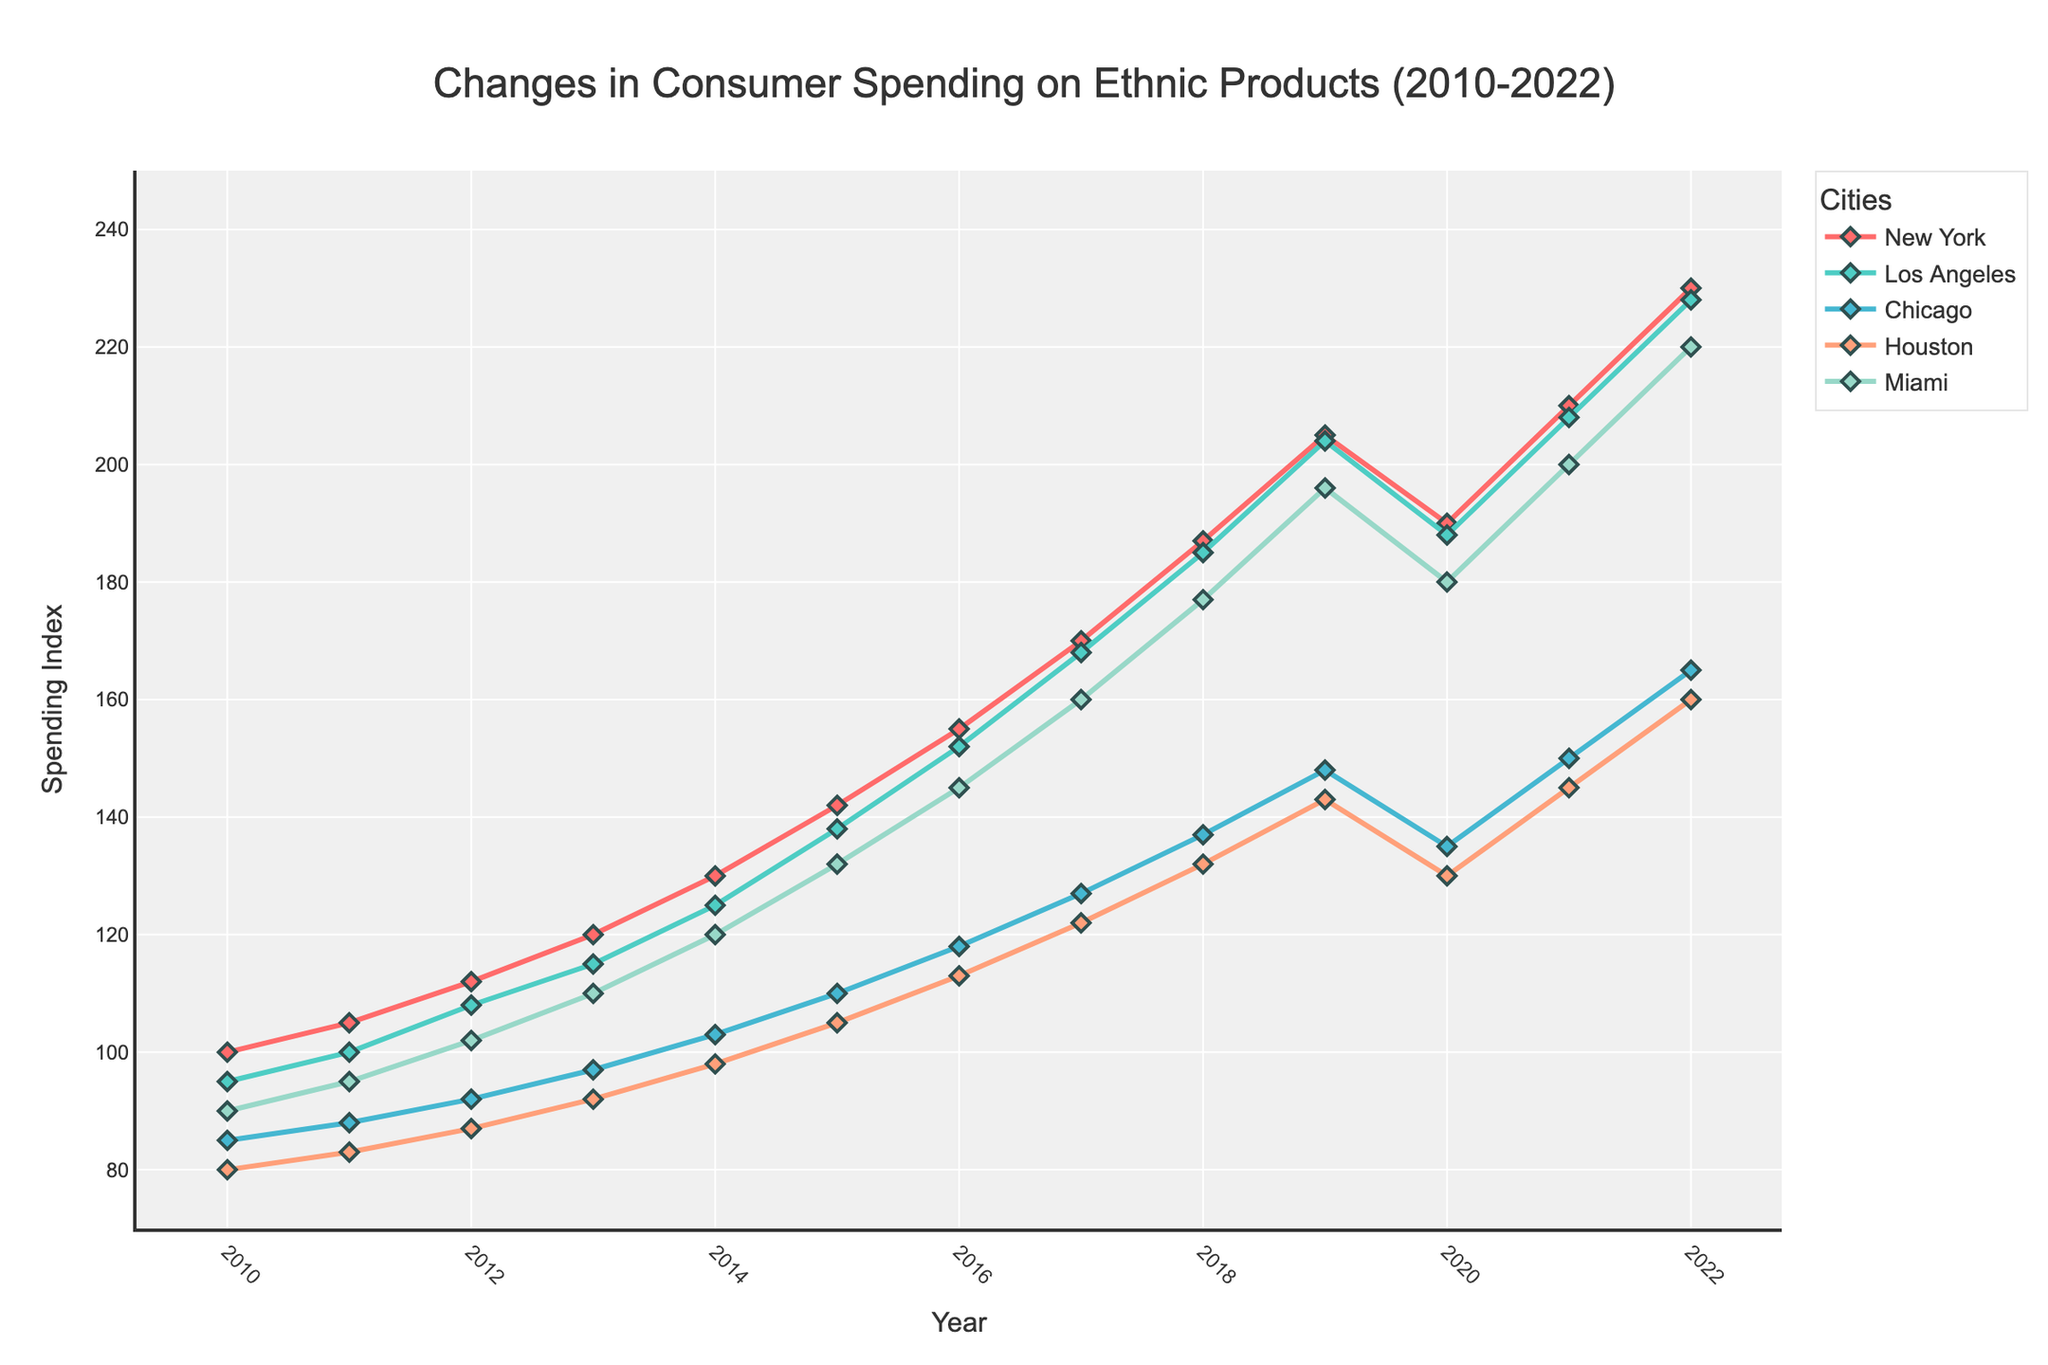What year did Miami see the highest consumer spending on ethnic products? The highest point on the line for Miami in the figure is at the top of the Miami line, which occurs in 2022.
Answer: 2022 By how much did Los Angeles consumer spending on ethnic products increase from 2010 to 2022? Find the value for Los Angeles in 2022 (228) and subtract the value in 2010 (95). The increase is 228 - 95.
Answer: 133 Which city had the smallest increase in consumer spending on ethnic products from 2021 to 2022? Compare the differences in values for all cities between 2021 and 2022: New York (20), Los Angeles (20), Chicago (15), Houston (15), and Miami (20). Houston and Chicago have the smallest increases of 15.
Answer: Houston and Chicago In 2016, which city had a higher consumer spending on ethnic products, Chicago or Houston? Look at the values for Chicago (118) and Houston (113) in 2016. Chicago's value is higher.
Answer: Chicago What is the average consumer spending on ethnic products in New York across the entire period from 2010 to 2022? Sum the values for New York from 2010 to 2022 and divide by the number of years (13): (100 + 105 + 112 + 120 + 130 + 142 + 155 + 170 + 187 + 205 + 190 + 210 + 230) / 13 = 1924 / 13.
Answer: 148 Which year saw the largest drop in consumer spending for New York? Identify the year with the largest decrease from one year to the next by comparing consecutive values. The largest drop for New York is from 2019 (205) to 2020 (190), a drop of 15.
Answer: 2020 Between 2013 and 2014, which city experienced the greatest relative increase in consumer spending on ethnic products? Calculate the percentage increase for each city between 2013 and 2014, then determine which is greatest: 
New York: (130-120)/120 = 8.33%
Los Angeles: (125-115)/115 = 8.70%
Chicago: (103-97)/97 = 6.19%
Houston: (98-92)/92 = 6.52%
Miami: (120-110)/110 = 9.09%
Miami has the greatest relative increase.
Answer: Miami By how much did consumer spending on ethnic products in Houston change from 2015 to 2016? Look at Houston's spending in 2015 (105) and 2016 (113). The change is 113 - 105.
Answer: 8 How does the consumer spending pattern in Miami in 2020 compare to 2019? Compare the value of Miami's spending in 2020 (180) to that in 2019 (196). The spending decreased by 16.
Answer: Decreased by 16 Which city had the highest consumer spending on ethnic products in 2015? Compare the values for all cities in 2015. The highest value is for Los Angeles (138).
Answer: Los Angeles 